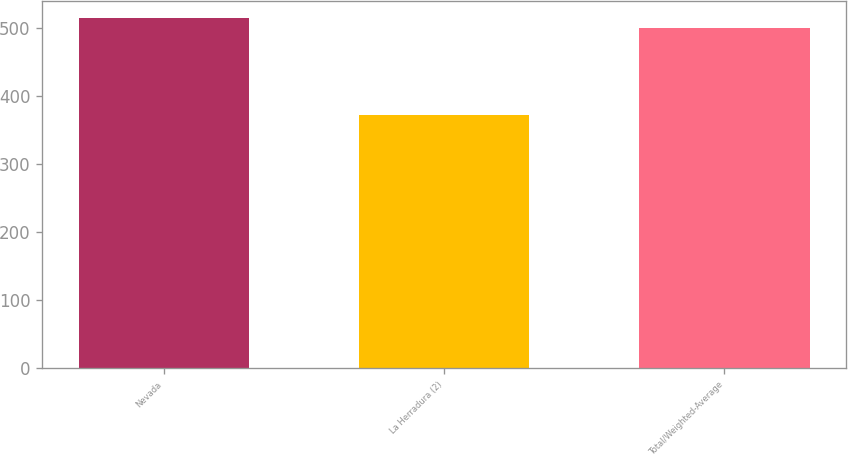Convert chart. <chart><loc_0><loc_0><loc_500><loc_500><bar_chart><fcel>Nevada<fcel>La Herradura (2)<fcel>Total/Weighted-Average<nl><fcel>514.7<fcel>372<fcel>501<nl></chart> 